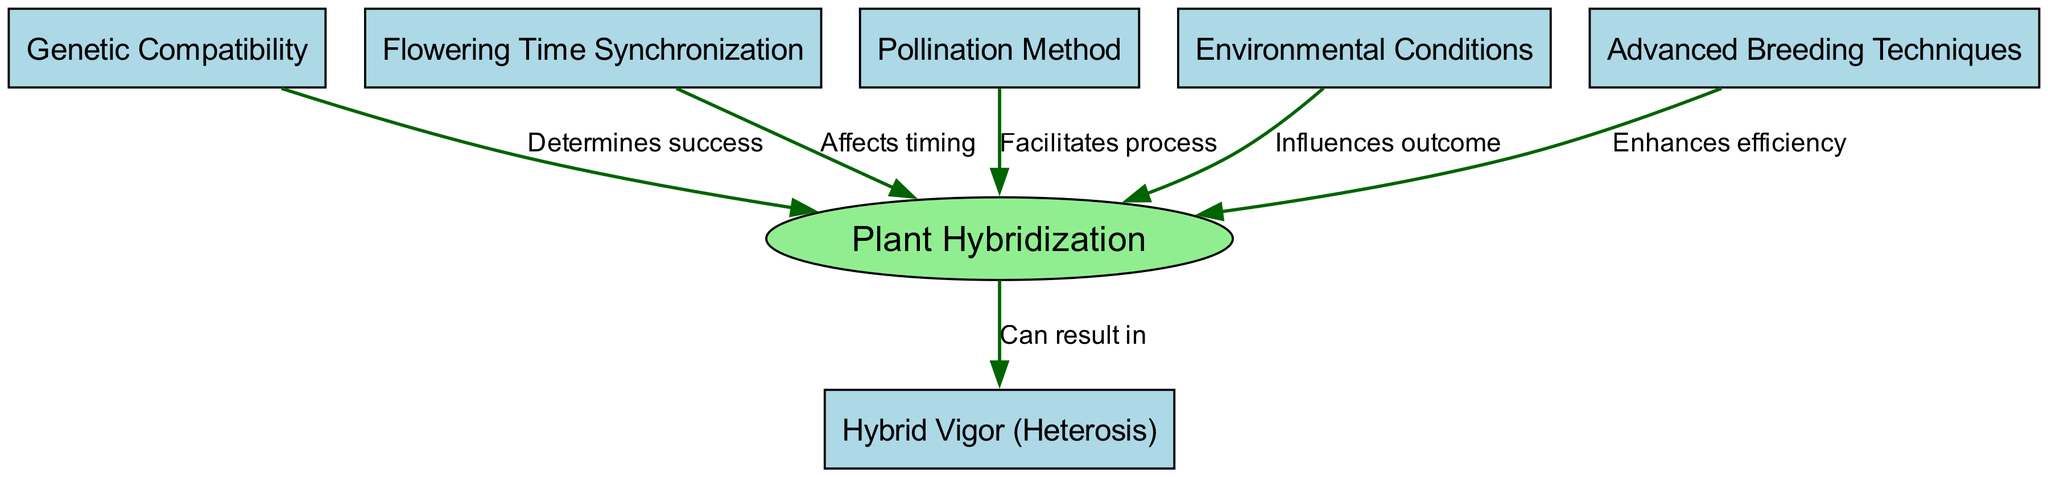What is the main subject of the diagram? The diagram focuses on "Plant Hybridization," which is the central node represented in an ellipse shape.
Answer: Plant Hybridization How many nodes are present in the diagram? The diagram lists a total of six nodes, each representing a key factor or concept related to plant hybridization.
Answer: 6 What does "Genetic Compatibility" determine? According to the diagram, "Genetic Compatibility" determines success in the process of plant hybridization, as indicated by the edge connecting the two.
Answer: Success What influences the outcome of hybridization? The diagram indicates that "Environmental Conditions" influence the outcome of plant hybridization, as shown by the directed edge from that node to the hybridization node.
Answer: Environmental Conditions What can result from successful hybridization? Based on the diagram, successful hybridization can result in "Hybrid Vigor (Heterosis)," as highlighted by the directed edge from hybridization to hybrid vigor.
Answer: Hybrid Vigor (Heterosis) How does "Advanced Breeding Techniques" affect hybridization? The diagram shows that "Advanced Breeding Techniques" enhances efficiency in the hybridization process, as indicated by the edge leading to the hybridization node.
Answer: Enhances efficiency Why is "Flowering Time Synchronization" important? "Flowering Time Synchronization" affects timing in the hybridization process, which is critical for ensuring that plants are ready to pollinate when needed.
Answer: Affects timing Which factor facilitates the process of hybridization? The factor that facilitates the process of hybridization is "Pollination Method," as indicated by the edge connecting it directly to hybridization.
Answer: Pollination Method What is the relationship between hybridization and hybrid vigor? The relationship indicated in the diagram shows that hybridization can lead to the occurrence of hybrid vigor, with a directed edge pointing from hybridization to hybrid vigor.
Answer: Can result in 